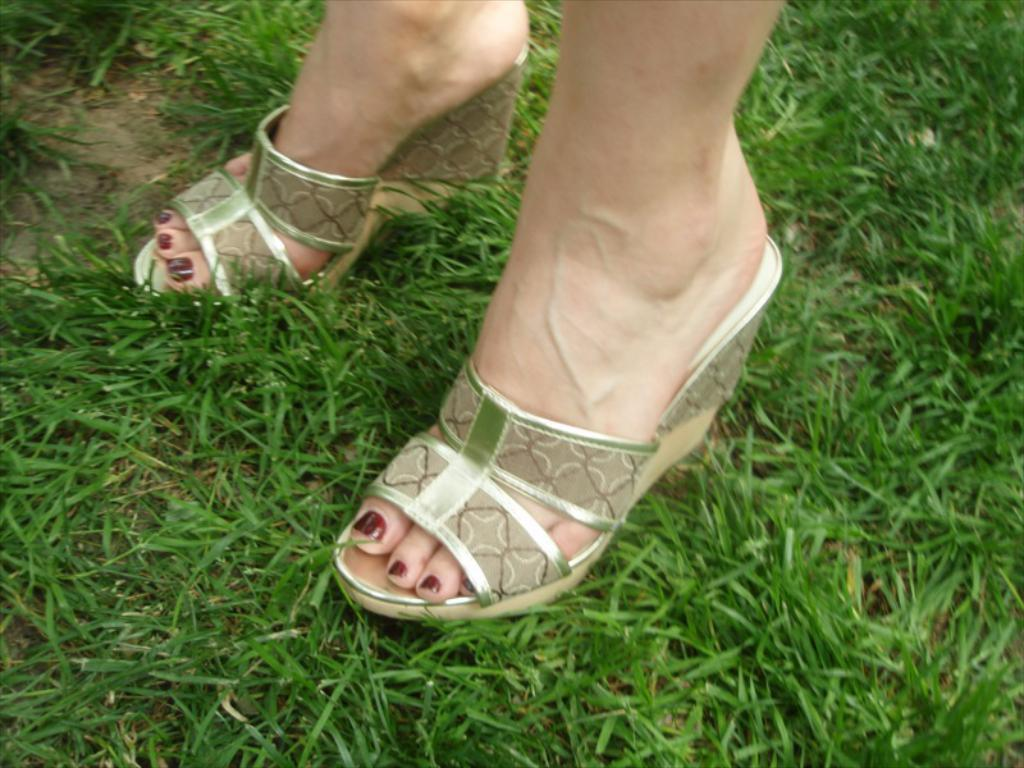Who is the main subject in the image? There is a lady in the image. What is the lady standing on? The lady is standing on a grassland. What type of jar is the lady holding in the image? There is no jar present in the image; the lady is not holding anything. 